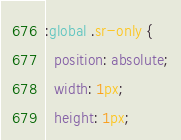Convert code to text. <code><loc_0><loc_0><loc_500><loc_500><_CSS_>:global .sr-only {
  position: absolute;
  width: 1px;
  height: 1px;</code> 